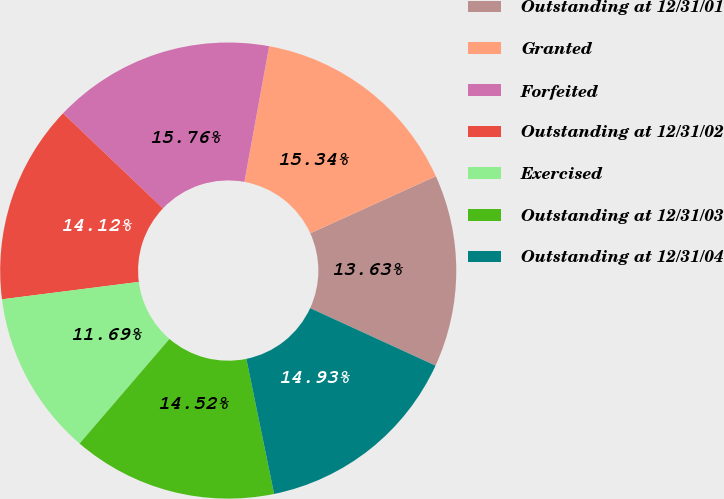Convert chart to OTSL. <chart><loc_0><loc_0><loc_500><loc_500><pie_chart><fcel>Outstanding at 12/31/01<fcel>Granted<fcel>Forfeited<fcel>Outstanding at 12/31/02<fcel>Exercised<fcel>Outstanding at 12/31/03<fcel>Outstanding at 12/31/04<nl><fcel>13.63%<fcel>15.34%<fcel>15.76%<fcel>14.12%<fcel>11.69%<fcel>14.52%<fcel>14.93%<nl></chart> 